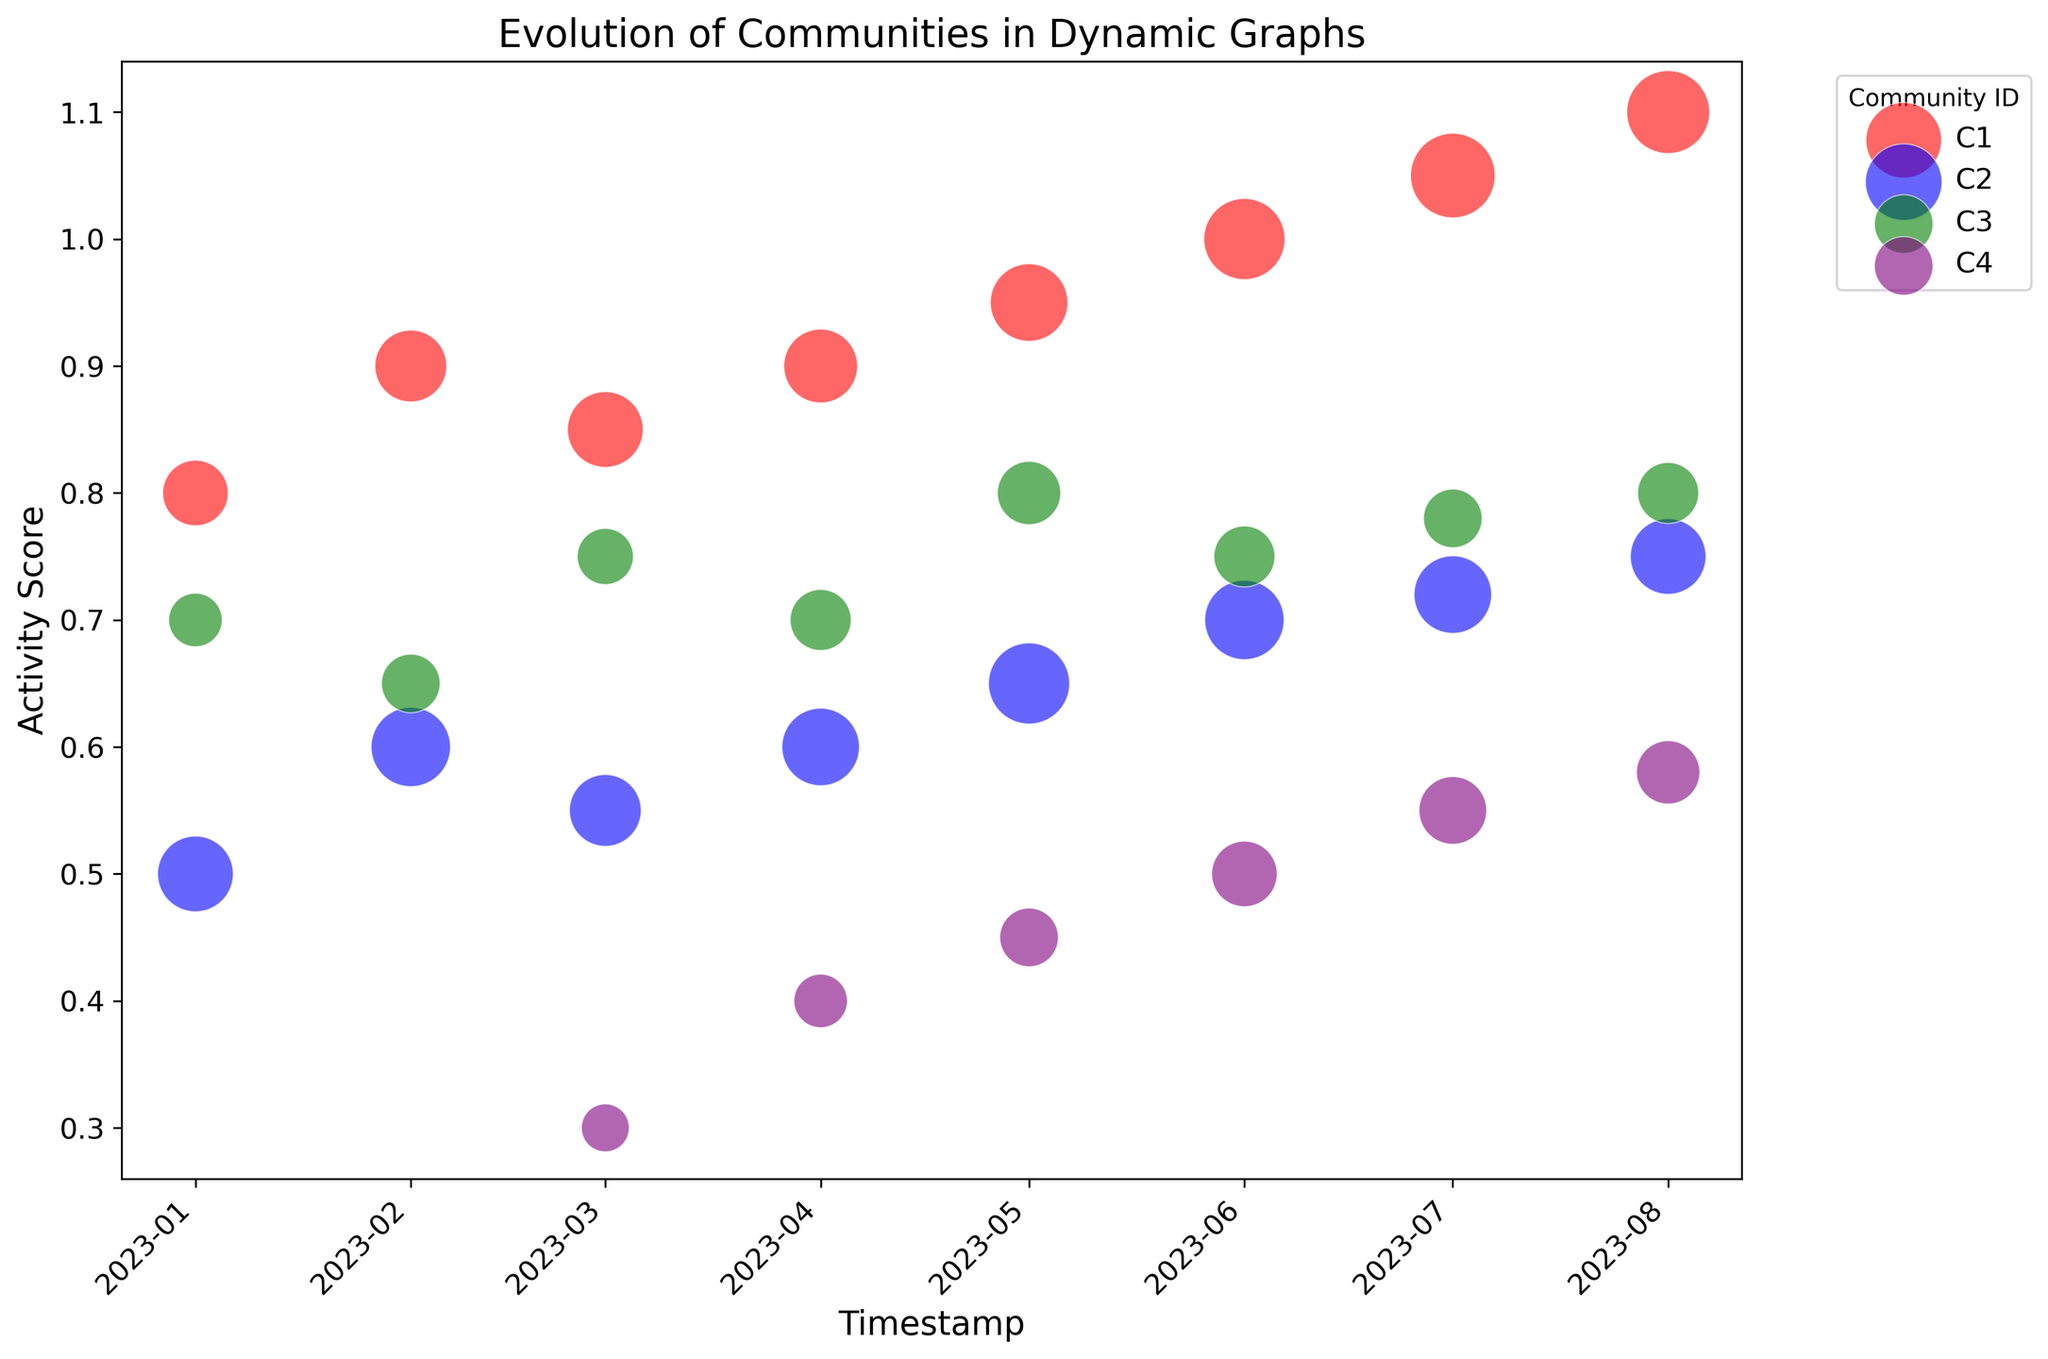Which community has the highest activity score on 2023-06-01? We look at the bubble corresponding to June 2023, identify the activity scores for each community, and find the highest value. Community C1 has the highest activity score of 1.0 on this date.
Answer: C1 What is the overall trend in node count for community C2 from 2023-01-01 to 2023-08-01? Examine the size of the bubbles for community C2 across the given timestamps. Initially, node count increases, reaching a peak around May 2023, then slightly decreases thereafter. The overall trend shows an initial increase followed by a slight decrease.
Answer: Initial increase, then decrease Compare the activity scores of communities C3 and C4 on 2023-04-01. Which community is more active? Identify the activity scores for C3 and C4 on April 2023. C3 has an activity score of 0.7, while C4 has 0.4. Thus, C3 is more active.
Answer: C3 What is the average node count for community C1 over the entire period? Summing up the node counts for community C1 for each timestamp from January to August (15 + 18 + 20 + 19 + 21 + 23 + 25 + 24 = 165) and then dividing by the number of observations (8), gives us an average of 165/8 = 20.625.
Answer: 20.625 How does the activity score of community C4 change from 2023-03-01 to 2023-08-01? Track the activity scores of community C4 over the given period (0.3, 0.4, 0.45, 0.5, 0.55, 0.58). The scores show a consistent increase.
Answer: Consistent increase Which timestamp shows the highest node count for community C3? Check the sizes of the bubbles representing community C3 across timestamps and find the largest one. The highest node count for C3 is on 2023-05-01 with a node count of 14.
Answer: 2023-05-01 What significant change happens for community C4 on 2023-03-01? Note that community C4 appears for the first time on the chart on 2023-03-01, indicating its formation in the dynamic graph.
Answer: Community C4 appears Which community shows the least variation in activity score over the entire period? Comparing the range of activity scores for all communities, community C2's scores range from 0.5 to 0.75 (minimal change), suggesting it shows the least variation.
Answer: C2 What are the color representations for each community in the chart? Identify the color used for each community in the chart's legend: C1 is red, C2 is blue, C3 is green, and C4 is purple.
Answer: C1 is red, C2 is blue, C3 is green, C4 is purple How does the activity score of community C1 evolve from 2023-01-01 to 2023-08-01? Follow the trajectory of the activity scores for community C1 over time (0.8, 0.9, 0.85, 0.9, 0.95, 1.0, 1.05, 1.1). It shows a steadily increasing trend.
Answer: Steadily increasing 